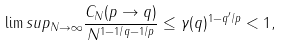<formula> <loc_0><loc_0><loc_500><loc_500>\lim s u p _ { N \to \infty } \frac { C _ { N } ( p \to q ) } { N ^ { 1 - 1 / q - 1 / p } } \leq \gamma ( q ) ^ { 1 - q ^ { \prime } / p } < 1 ,</formula> 